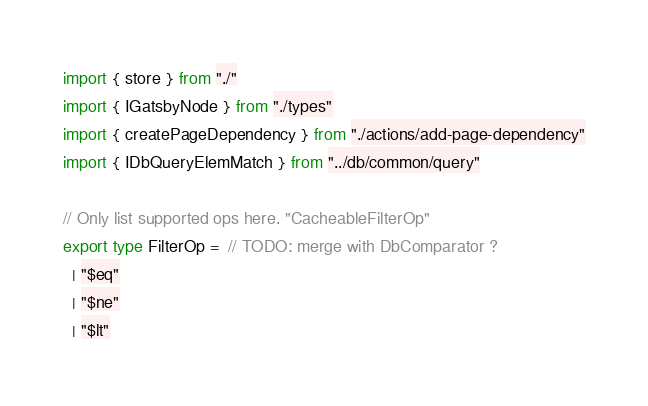Convert code to text. <code><loc_0><loc_0><loc_500><loc_500><_TypeScript_>import { store } from "./"
import { IGatsbyNode } from "./types"
import { createPageDependency } from "./actions/add-page-dependency"
import { IDbQueryElemMatch } from "../db/common/query"

// Only list supported ops here. "CacheableFilterOp"
export type FilterOp =  // TODO: merge with DbComparator ?
  | "$eq"
  | "$ne"
  | "$lt"</code> 